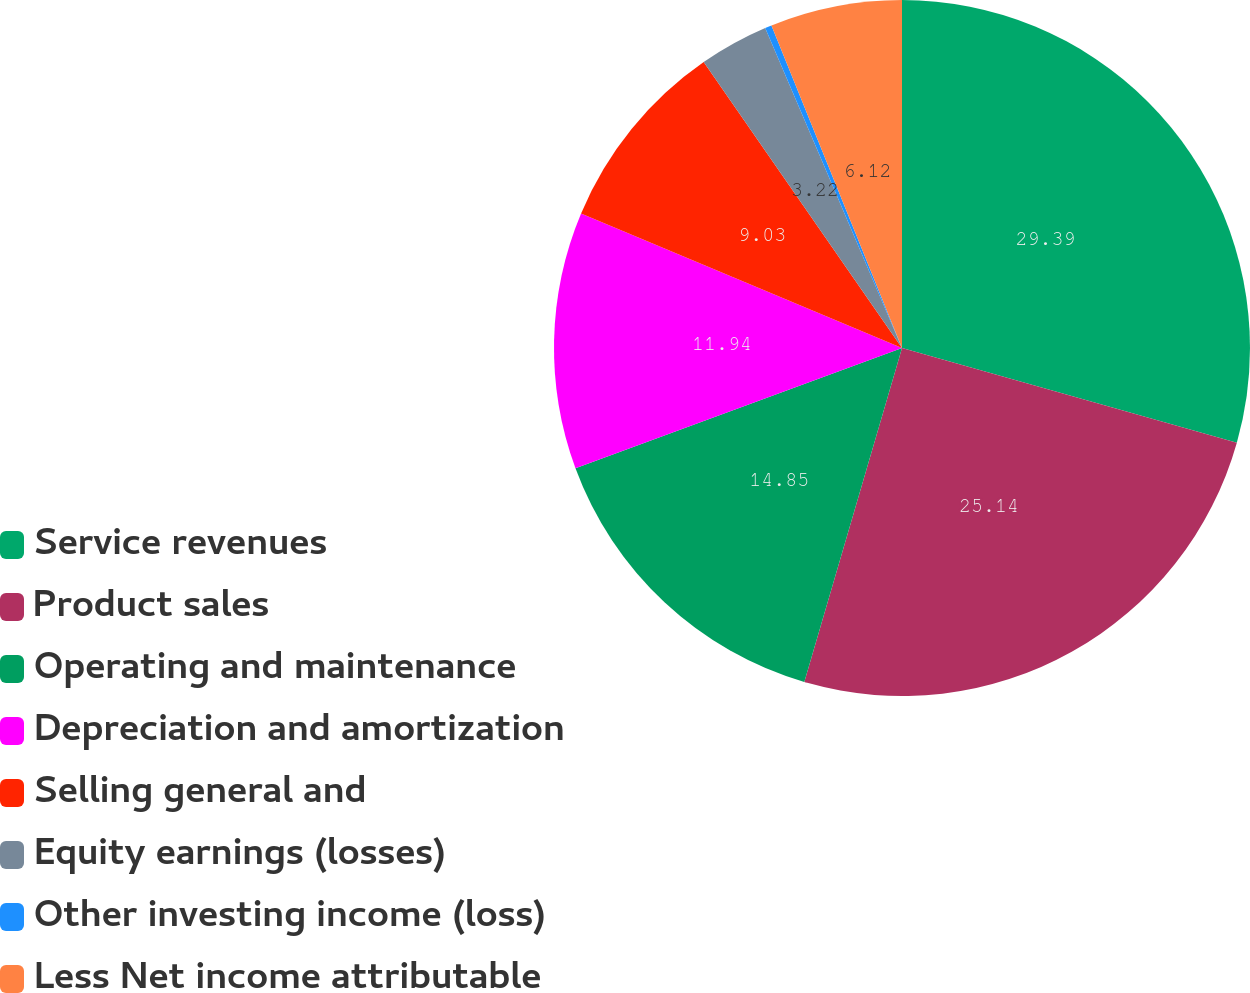Convert chart to OTSL. <chart><loc_0><loc_0><loc_500><loc_500><pie_chart><fcel>Service revenues<fcel>Product sales<fcel>Operating and maintenance<fcel>Depreciation and amortization<fcel>Selling general and<fcel>Equity earnings (losses)<fcel>Other investing income (loss)<fcel>Less Net income attributable<nl><fcel>29.39%<fcel>25.14%<fcel>14.85%<fcel>11.94%<fcel>9.03%<fcel>3.22%<fcel>0.31%<fcel>6.12%<nl></chart> 